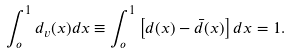<formula> <loc_0><loc_0><loc_500><loc_500>\int _ { o } ^ { 1 } { d _ { v } ( x ) d x } \equiv \int _ { o } ^ { 1 } \left [ d ( x ) - \bar { d } ( x ) \right ] d x = 1 .</formula> 